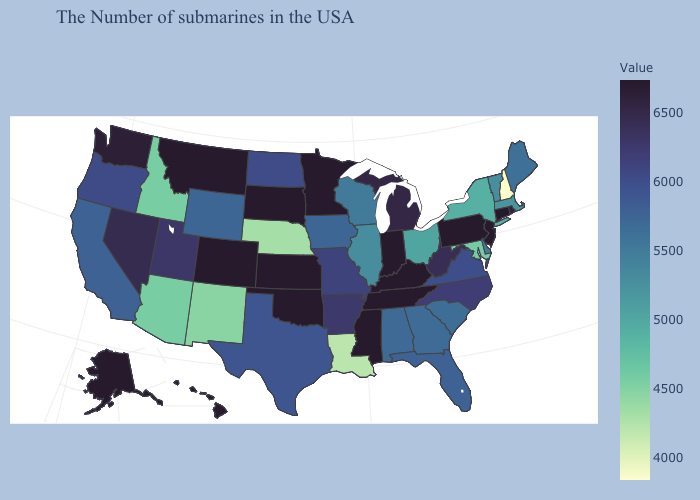Does Nebraska have the lowest value in the MidWest?
Short answer required. Yes. Does New Hampshire have the lowest value in the USA?
Be succinct. Yes. Does Alaska have a lower value than Vermont?
Be succinct. No. Does the map have missing data?
Keep it brief. No. Does the map have missing data?
Be succinct. No. Which states have the highest value in the USA?
Answer briefly. Connecticut, New Jersey, Pennsylvania, Kentucky, Indiana, Tennessee, Mississippi, Minnesota, Kansas, Oklahoma, South Dakota, Colorado, Montana, Alaska, Hawaii. 